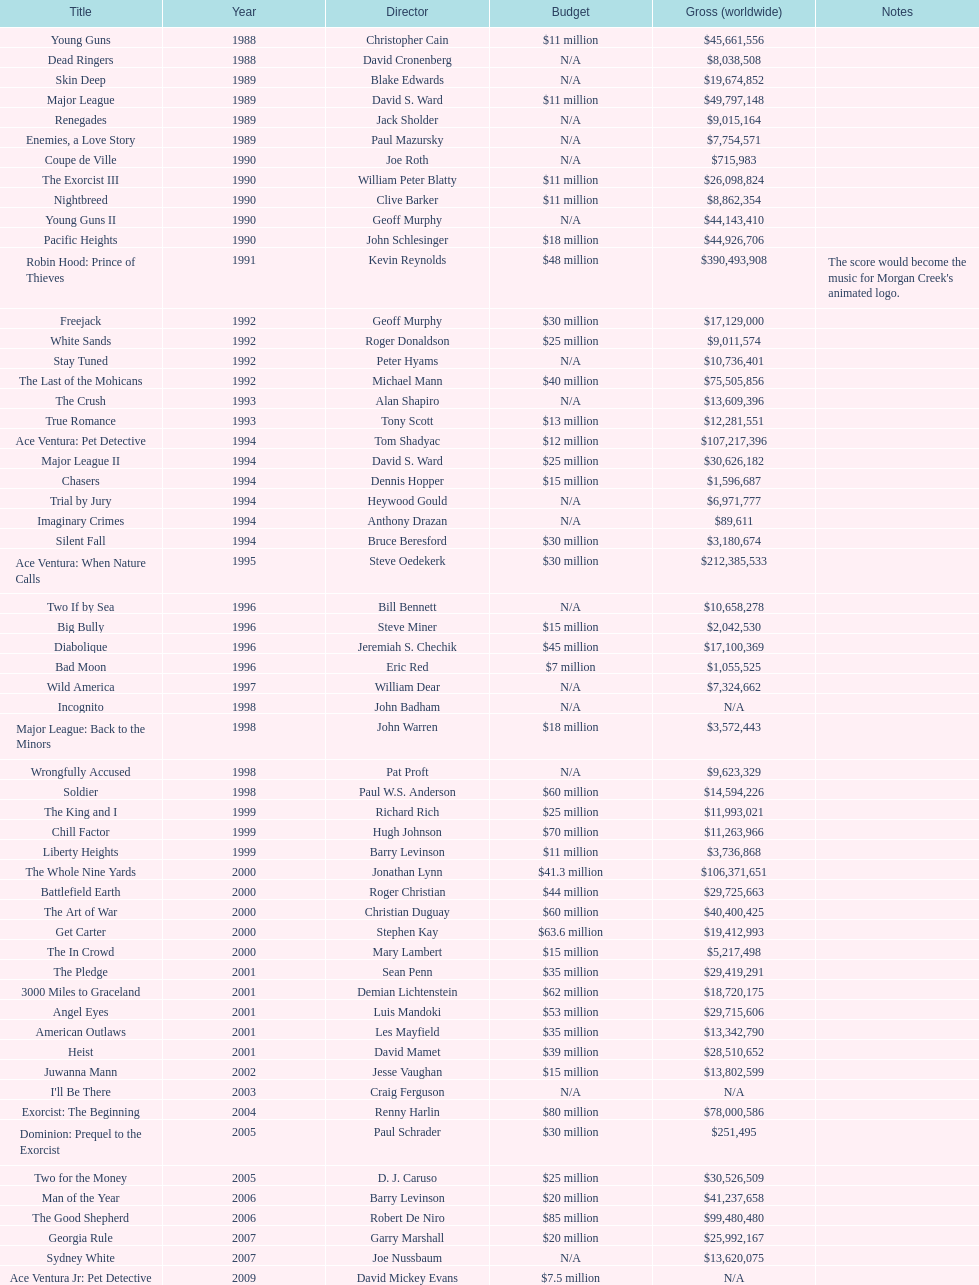Which was the final movie created by morgan creek that had a budget under $30 million? Ace Ventura Jr: Pet Detective. Could you parse the entire table as a dict? {'header': ['Title', 'Year', 'Director', 'Budget', 'Gross (worldwide)', 'Notes'], 'rows': [['Young Guns', '1988', 'Christopher Cain', '$11 million', '$45,661,556', ''], ['Dead Ringers', '1988', 'David Cronenberg', 'N/A', '$8,038,508', ''], ['Skin Deep', '1989', 'Blake Edwards', 'N/A', '$19,674,852', ''], ['Major League', '1989', 'David S. Ward', '$11 million', '$49,797,148', ''], ['Renegades', '1989', 'Jack Sholder', 'N/A', '$9,015,164', ''], ['Enemies, a Love Story', '1989', 'Paul Mazursky', 'N/A', '$7,754,571', ''], ['Coupe de Ville', '1990', 'Joe Roth', 'N/A', '$715,983', ''], ['The Exorcist III', '1990', 'William Peter Blatty', '$11 million', '$26,098,824', ''], ['Nightbreed', '1990', 'Clive Barker', '$11 million', '$8,862,354', ''], ['Young Guns II', '1990', 'Geoff Murphy', 'N/A', '$44,143,410', ''], ['Pacific Heights', '1990', 'John Schlesinger', '$18 million', '$44,926,706', ''], ['Robin Hood: Prince of Thieves', '1991', 'Kevin Reynolds', '$48 million', '$390,493,908', "The score would become the music for Morgan Creek's animated logo."], ['Freejack', '1992', 'Geoff Murphy', '$30 million', '$17,129,000', ''], ['White Sands', '1992', 'Roger Donaldson', '$25 million', '$9,011,574', ''], ['Stay Tuned', '1992', 'Peter Hyams', 'N/A', '$10,736,401', ''], ['The Last of the Mohicans', '1992', 'Michael Mann', '$40 million', '$75,505,856', ''], ['The Crush', '1993', 'Alan Shapiro', 'N/A', '$13,609,396', ''], ['True Romance', '1993', 'Tony Scott', '$13 million', '$12,281,551', ''], ['Ace Ventura: Pet Detective', '1994', 'Tom Shadyac', '$12 million', '$107,217,396', ''], ['Major League II', '1994', 'David S. Ward', '$25 million', '$30,626,182', ''], ['Chasers', '1994', 'Dennis Hopper', '$15 million', '$1,596,687', ''], ['Trial by Jury', '1994', 'Heywood Gould', 'N/A', '$6,971,777', ''], ['Imaginary Crimes', '1994', 'Anthony Drazan', 'N/A', '$89,611', ''], ['Silent Fall', '1994', 'Bruce Beresford', '$30 million', '$3,180,674', ''], ['Ace Ventura: When Nature Calls', '1995', 'Steve Oedekerk', '$30 million', '$212,385,533', ''], ['Two If by Sea', '1996', 'Bill Bennett', 'N/A', '$10,658,278', ''], ['Big Bully', '1996', 'Steve Miner', '$15 million', '$2,042,530', ''], ['Diabolique', '1996', 'Jeremiah S. Chechik', '$45 million', '$17,100,369', ''], ['Bad Moon', '1996', 'Eric Red', '$7 million', '$1,055,525', ''], ['Wild America', '1997', 'William Dear', 'N/A', '$7,324,662', ''], ['Incognito', '1998', 'John Badham', 'N/A', 'N/A', ''], ['Major League: Back to the Minors', '1998', 'John Warren', '$18 million', '$3,572,443', ''], ['Wrongfully Accused', '1998', 'Pat Proft', 'N/A', '$9,623,329', ''], ['Soldier', '1998', 'Paul W.S. Anderson', '$60 million', '$14,594,226', ''], ['The King and I', '1999', 'Richard Rich', '$25 million', '$11,993,021', ''], ['Chill Factor', '1999', 'Hugh Johnson', '$70 million', '$11,263,966', ''], ['Liberty Heights', '1999', 'Barry Levinson', '$11 million', '$3,736,868', ''], ['The Whole Nine Yards', '2000', 'Jonathan Lynn', '$41.3 million', '$106,371,651', ''], ['Battlefield Earth', '2000', 'Roger Christian', '$44 million', '$29,725,663', ''], ['The Art of War', '2000', 'Christian Duguay', '$60 million', '$40,400,425', ''], ['Get Carter', '2000', 'Stephen Kay', '$63.6 million', '$19,412,993', ''], ['The In Crowd', '2000', 'Mary Lambert', '$15 million', '$5,217,498', ''], ['The Pledge', '2001', 'Sean Penn', '$35 million', '$29,419,291', ''], ['3000 Miles to Graceland', '2001', 'Demian Lichtenstein', '$62 million', '$18,720,175', ''], ['Angel Eyes', '2001', 'Luis Mandoki', '$53 million', '$29,715,606', ''], ['American Outlaws', '2001', 'Les Mayfield', '$35 million', '$13,342,790', ''], ['Heist', '2001', 'David Mamet', '$39 million', '$28,510,652', ''], ['Juwanna Mann', '2002', 'Jesse Vaughan', '$15 million', '$13,802,599', ''], ["I'll Be There", '2003', 'Craig Ferguson', 'N/A', 'N/A', ''], ['Exorcist: The Beginning', '2004', 'Renny Harlin', '$80 million', '$78,000,586', ''], ['Dominion: Prequel to the Exorcist', '2005', 'Paul Schrader', '$30 million', '$251,495', ''], ['Two for the Money', '2005', 'D. J. Caruso', '$25 million', '$30,526,509', ''], ['Man of the Year', '2006', 'Barry Levinson', '$20 million', '$41,237,658', ''], ['The Good Shepherd', '2006', 'Robert De Niro', '$85 million', '$99,480,480', ''], ['Georgia Rule', '2007', 'Garry Marshall', '$20 million', '$25,992,167', ''], ['Sydney White', '2007', 'Joe Nussbaum', 'N/A', '$13,620,075', ''], ['Ace Ventura Jr: Pet Detective', '2009', 'David Mickey Evans', '$7.5 million', 'N/A', ''], ['Dream House', '2011', 'Jim Sheridan', '$50 million', '$38,502,340', ''], ['The Thing', '2011', 'Matthijs van Heijningen Jr.', '$38 million', '$27,428,670', ''], ['Tupac', '2014', 'Antoine Fuqua', '$45 million', '', '']]} 